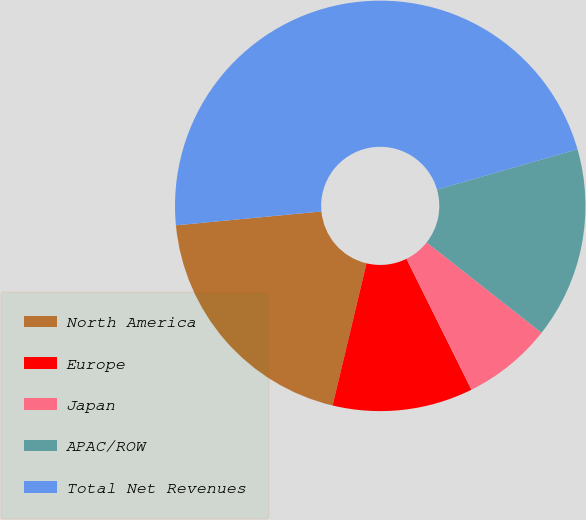<chart> <loc_0><loc_0><loc_500><loc_500><pie_chart><fcel>North America<fcel>Europe<fcel>Japan<fcel>APAC/ROW<fcel>Total Net Revenues<nl><fcel>19.76%<fcel>11.06%<fcel>7.06%<fcel>15.06%<fcel>47.06%<nl></chart> 